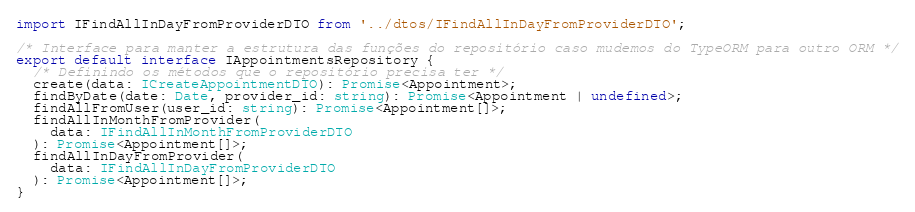Convert code to text. <code><loc_0><loc_0><loc_500><loc_500><_TypeScript_>import IFindAllInDayFromProviderDTO from '../dtos/IFindAllInDayFromProviderDTO';

/* Interface para manter a estrutura das funções do repositório caso mudemos do TypeORM para outro ORM */
export default interface IAppointmentsRepository {
  /* Definindo os métodos que o repositório precisa ter */
  create(data: ICreateAppointmentDTO): Promise<Appointment>;
  findByDate(date: Date, provider_id: string): Promise<Appointment | undefined>;
  findAllFromUser(user_id: string): Promise<Appointment[]>;
  findAllInMonthFromProvider(
    data: IFindAllInMonthFromProviderDTO
  ): Promise<Appointment[]>;
  findAllInDayFromProvider(
    data: IFindAllInDayFromProviderDTO
  ): Promise<Appointment[]>;
}
</code> 